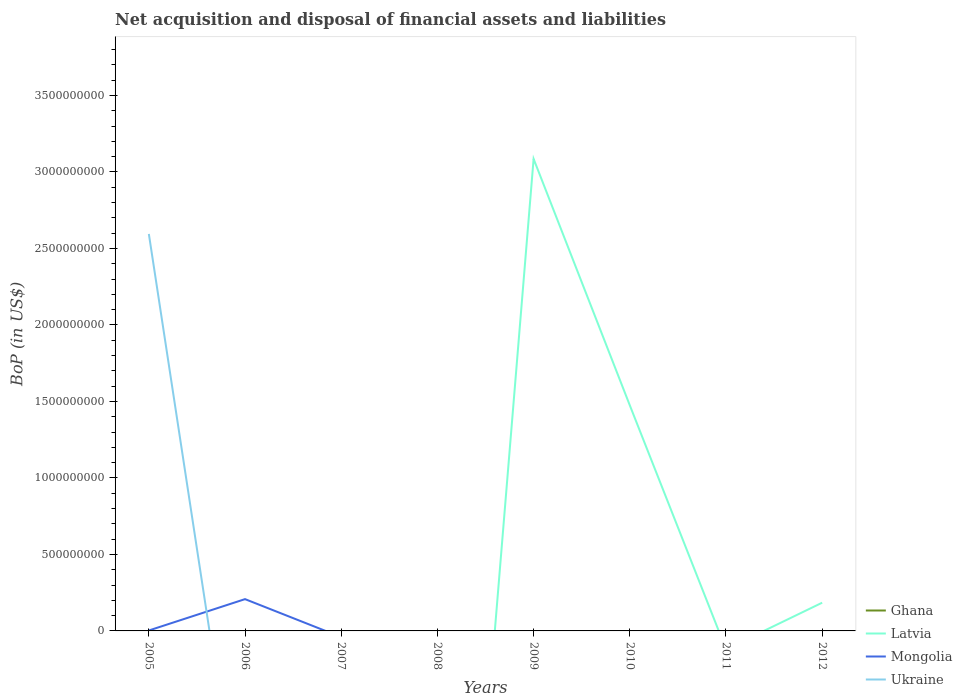How many different coloured lines are there?
Provide a short and direct response. 3. Does the line corresponding to Ghana intersect with the line corresponding to Latvia?
Your answer should be very brief. Yes. What is the difference between the highest and the second highest Balance of Payments in Ukraine?
Keep it short and to the point. 2.60e+09. Is the Balance of Payments in Ghana strictly greater than the Balance of Payments in Ukraine over the years?
Keep it short and to the point. No. Are the values on the major ticks of Y-axis written in scientific E-notation?
Offer a very short reply. No. Does the graph contain any zero values?
Keep it short and to the point. Yes. Does the graph contain grids?
Give a very brief answer. No. Where does the legend appear in the graph?
Give a very brief answer. Bottom right. What is the title of the graph?
Keep it short and to the point. Net acquisition and disposal of financial assets and liabilities. What is the label or title of the X-axis?
Offer a terse response. Years. What is the label or title of the Y-axis?
Your answer should be very brief. BoP (in US$). What is the BoP (in US$) of Mongolia in 2005?
Offer a terse response. 2.91e+06. What is the BoP (in US$) of Ukraine in 2005?
Offer a very short reply. 2.60e+09. What is the BoP (in US$) in Ghana in 2006?
Make the answer very short. 0. What is the BoP (in US$) of Latvia in 2006?
Provide a succinct answer. 0. What is the BoP (in US$) in Mongolia in 2006?
Keep it short and to the point. 2.08e+08. What is the BoP (in US$) of Ukraine in 2006?
Offer a very short reply. 0. What is the BoP (in US$) in Ghana in 2007?
Keep it short and to the point. 0. What is the BoP (in US$) of Mongolia in 2007?
Provide a short and direct response. 0. What is the BoP (in US$) of Ukraine in 2007?
Give a very brief answer. 0. What is the BoP (in US$) in Mongolia in 2008?
Offer a terse response. 0. What is the BoP (in US$) in Latvia in 2009?
Give a very brief answer. 3.09e+09. What is the BoP (in US$) in Ghana in 2010?
Give a very brief answer. 0. What is the BoP (in US$) of Latvia in 2010?
Keep it short and to the point. 1.47e+09. What is the BoP (in US$) of Mongolia in 2010?
Provide a short and direct response. 0. What is the BoP (in US$) of Latvia in 2011?
Provide a succinct answer. 0. What is the BoP (in US$) of Mongolia in 2011?
Give a very brief answer. 0. What is the BoP (in US$) of Latvia in 2012?
Your answer should be very brief. 1.84e+08. What is the BoP (in US$) of Ukraine in 2012?
Offer a terse response. 0. Across all years, what is the maximum BoP (in US$) in Latvia?
Keep it short and to the point. 3.09e+09. Across all years, what is the maximum BoP (in US$) in Mongolia?
Your answer should be very brief. 2.08e+08. Across all years, what is the maximum BoP (in US$) in Ukraine?
Offer a very short reply. 2.60e+09. Across all years, what is the minimum BoP (in US$) of Mongolia?
Your answer should be compact. 0. What is the total BoP (in US$) of Latvia in the graph?
Offer a very short reply. 4.75e+09. What is the total BoP (in US$) in Mongolia in the graph?
Keep it short and to the point. 2.11e+08. What is the total BoP (in US$) of Ukraine in the graph?
Your response must be concise. 2.60e+09. What is the difference between the BoP (in US$) in Mongolia in 2005 and that in 2006?
Provide a succinct answer. -2.05e+08. What is the difference between the BoP (in US$) in Latvia in 2009 and that in 2010?
Give a very brief answer. 1.61e+09. What is the difference between the BoP (in US$) in Latvia in 2009 and that in 2012?
Ensure brevity in your answer.  2.90e+09. What is the difference between the BoP (in US$) in Latvia in 2010 and that in 2012?
Offer a terse response. 1.29e+09. What is the average BoP (in US$) of Latvia per year?
Give a very brief answer. 5.93e+08. What is the average BoP (in US$) in Mongolia per year?
Ensure brevity in your answer.  2.63e+07. What is the average BoP (in US$) of Ukraine per year?
Offer a very short reply. 3.24e+08. In the year 2005, what is the difference between the BoP (in US$) of Mongolia and BoP (in US$) of Ukraine?
Make the answer very short. -2.59e+09. What is the ratio of the BoP (in US$) of Mongolia in 2005 to that in 2006?
Ensure brevity in your answer.  0.01. What is the ratio of the BoP (in US$) in Latvia in 2009 to that in 2010?
Your answer should be compact. 2.09. What is the ratio of the BoP (in US$) in Latvia in 2009 to that in 2012?
Provide a succinct answer. 16.73. What is the ratio of the BoP (in US$) of Latvia in 2010 to that in 2012?
Offer a very short reply. 7.99. What is the difference between the highest and the second highest BoP (in US$) of Latvia?
Keep it short and to the point. 1.61e+09. What is the difference between the highest and the lowest BoP (in US$) in Latvia?
Provide a short and direct response. 3.09e+09. What is the difference between the highest and the lowest BoP (in US$) of Mongolia?
Provide a succinct answer. 2.08e+08. What is the difference between the highest and the lowest BoP (in US$) in Ukraine?
Make the answer very short. 2.60e+09. 